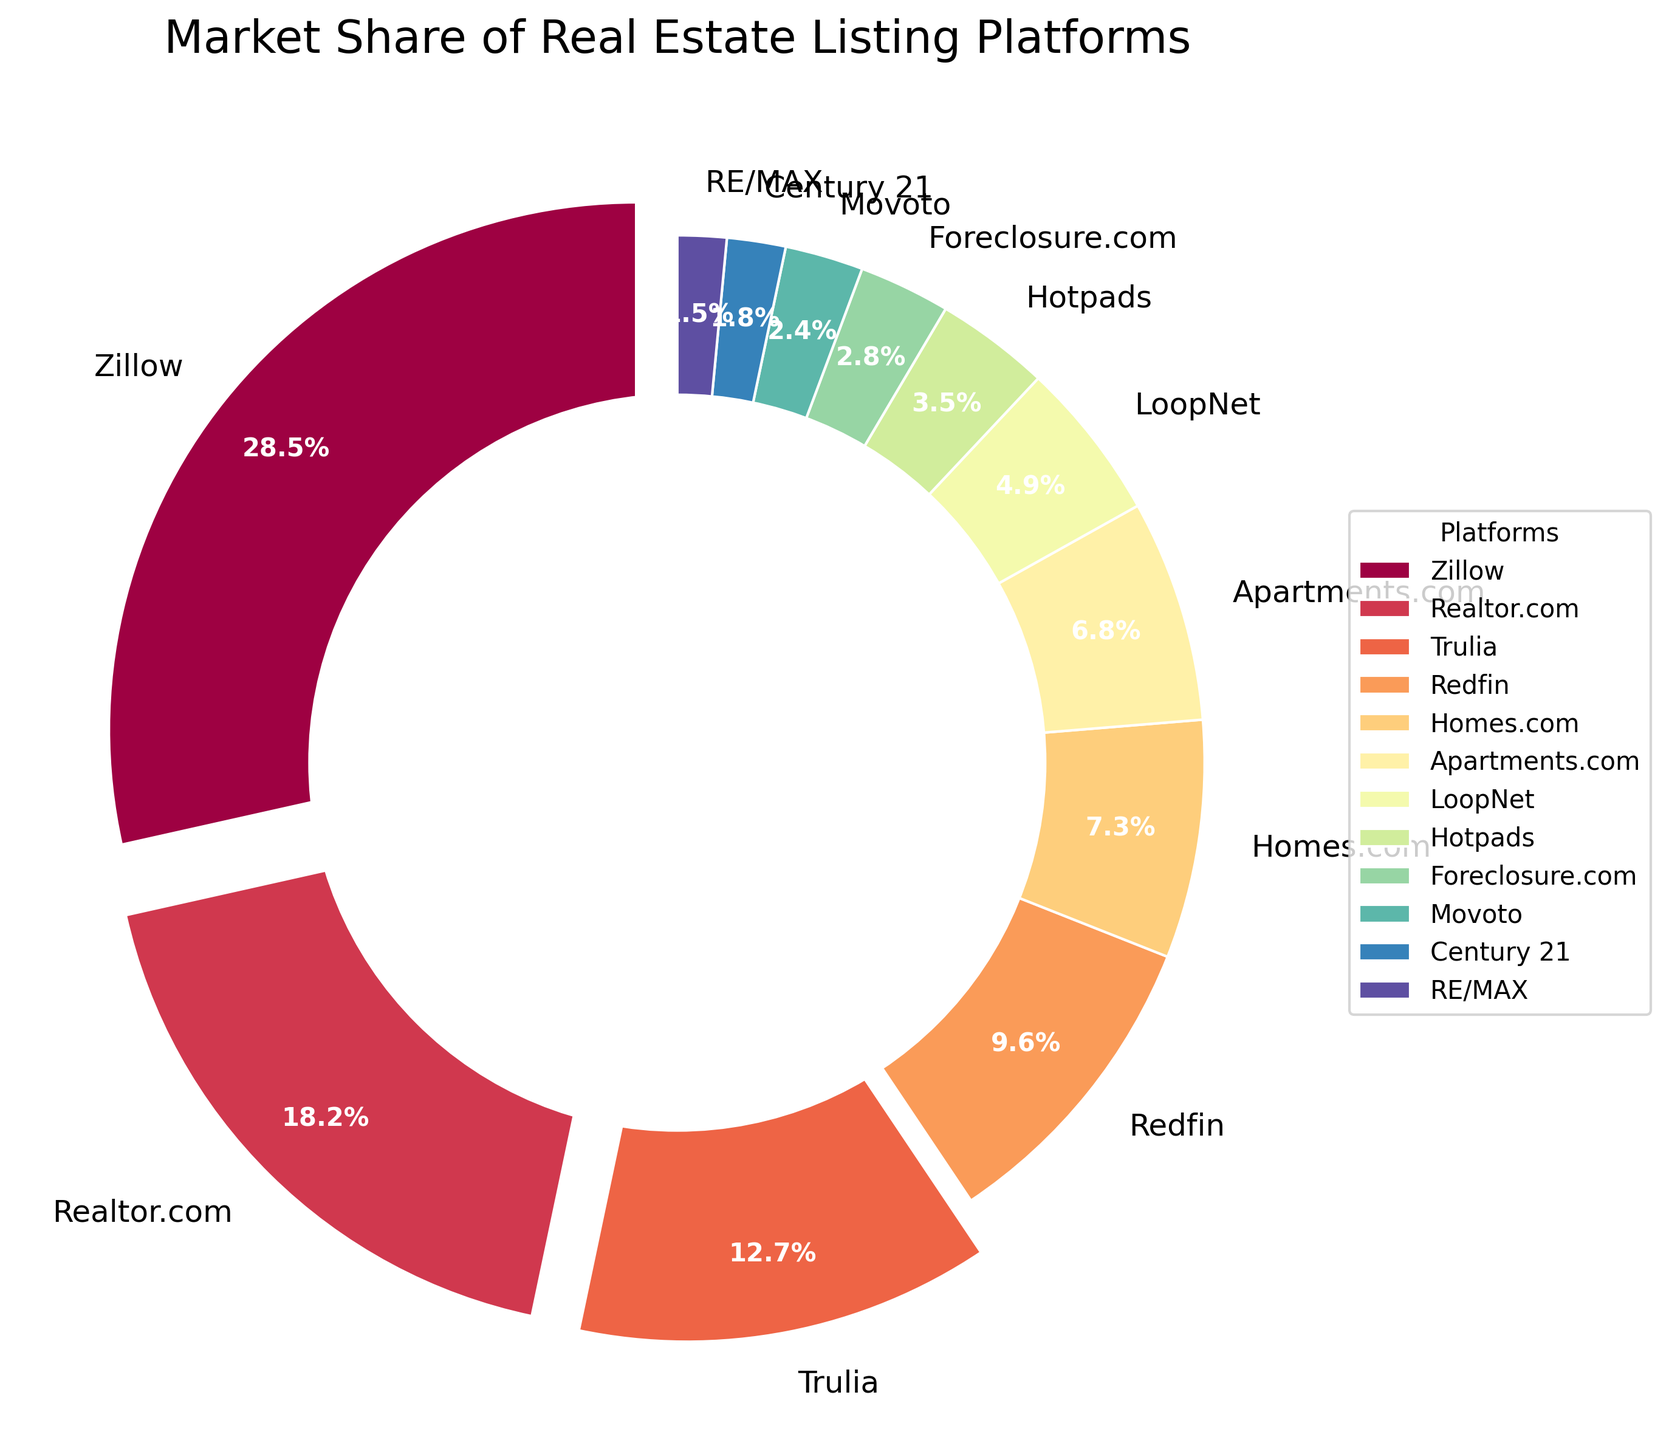Which platform has the largest market share? The figure shows the market share for each platform with percentages. Zillow has the highest percentage at 28.5%.
Answer: Zillow What is the combined market share of Zillow and Realtor.com? Zillow's market share is 28.5% and Realtor.com's market share is 18.2%. Adding them together, 28.5 + 18.2 = 46.7.
Answer: 46.7% How many platforms have a market share greater than 10%? The figure uses colors to differentiate platforms and also highlights the platforms with a market share greater than 10% by exploding their wedges. Counting these, we have Zillow (28.5%), Realtor.com (18.2%), and Trulia (12.7%).
Answer: 3 Which platform has a smaller market share: Homes.com or Redfin? Comparing the market share percentages from the figure, Homes.com has 7.3% and Redfin has 9.6%. Homes.com has a smaller share.
Answer: Homes.com What is the total market share of platforms that individually have less than 5% of the market? Adding the shares of LoopNet (4.9%), Hotpads (3.5%), Foreclosure.com (2.8%), Movoto (2.4%), Century 21 (1.8%), and RE/MAX (1.5%), we get 4.9 + 3.5 + 2.8 + 2.4 + 1.8 + 1.5 = 16.9.
Answer: 16.9% Which platform is depicted using the largest wedge in the pie chart? The largest wedge corresponds to the platform with the largest market share. Zillow, with 28.5%, has the largest wedge.
Answer: Zillow Is the market share of Apartments.com closer to that of Homes.com or Hotpads? Apartments.com has a 6.8% share, while Homes.com has 7.3% and Hotpads has 3.5%. The difference from Homes.com is 7.3 - 6.8 = 0.5%, and the difference from Hotpads is 6.8 - 3.5 = 3.3%. Apartments.com is closer to Homes.com.
Answer: Homes.com What is the average market share of the top 4 platforms? The top 4 platforms are Zillow (28.5%), Realtor.com (18.2%), Trulia (12.7%), and Redfin (9.6%). Adding these, 28.5 + 18.2 + 12.7 + 9.6 = 69. Then dividing by 4, 69 / 4 = 17.25.
Answer: 17.25% Which platform has the smallest market share? The figure displays that RE/MAX has the smallest market share at 1.5%.
Answer: RE/MAX 